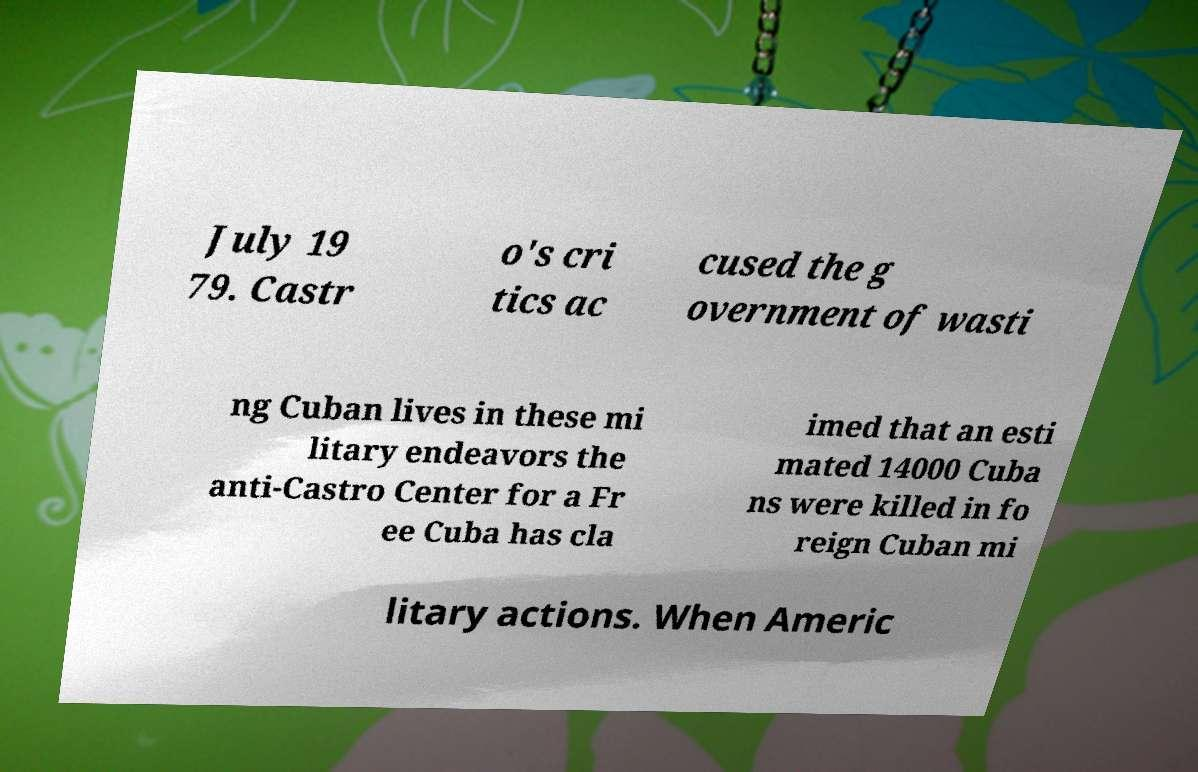Could you extract and type out the text from this image? July 19 79. Castr o's cri tics ac cused the g overnment of wasti ng Cuban lives in these mi litary endeavors the anti-Castro Center for a Fr ee Cuba has cla imed that an esti mated 14000 Cuba ns were killed in fo reign Cuban mi litary actions. When Americ 